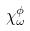Convert formula to latex. <formula><loc_0><loc_0><loc_500><loc_500>\chi _ { \omega } ^ { \phi }</formula> 